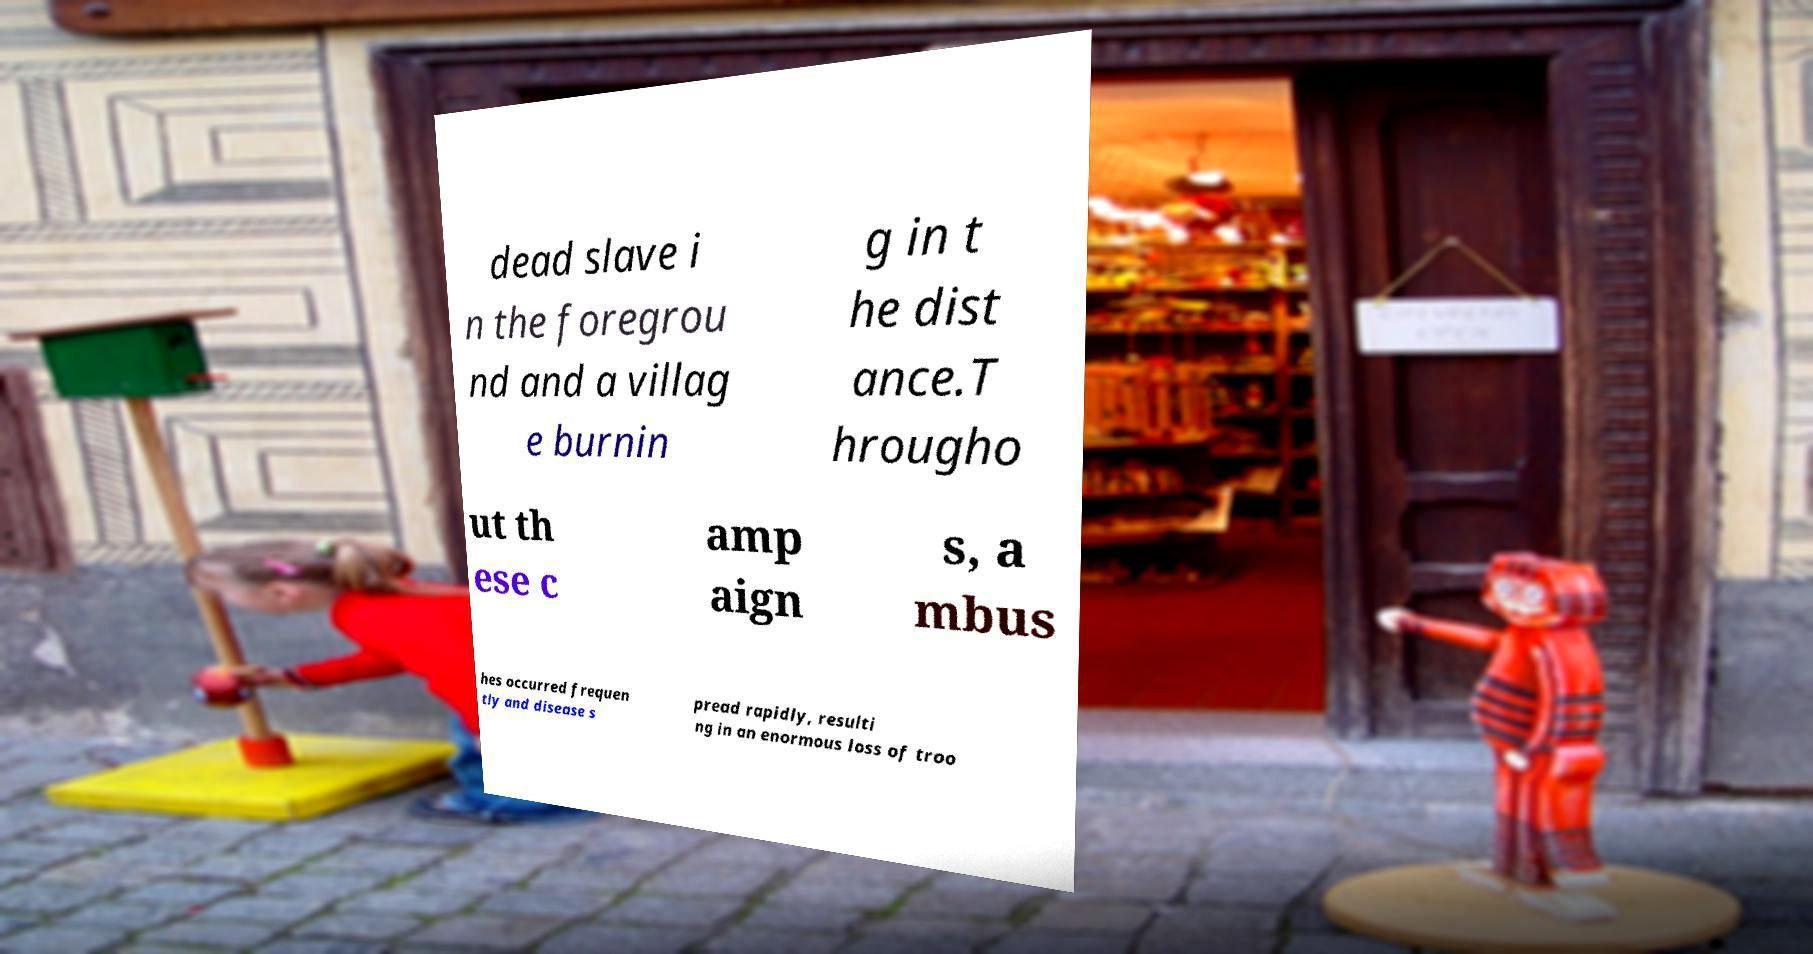Please read and relay the text visible in this image. What does it say? dead slave i n the foregrou nd and a villag e burnin g in t he dist ance.T hrougho ut th ese c amp aign s, a mbus hes occurred frequen tly and disease s pread rapidly, resulti ng in an enormous loss of troo 